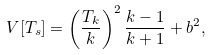<formula> <loc_0><loc_0><loc_500><loc_500>V [ T _ { s } ] = \left ( \frac { T _ { k } } { k } \right ) ^ { 2 } \frac { k - 1 } { k + 1 } + b ^ { 2 } ,</formula> 